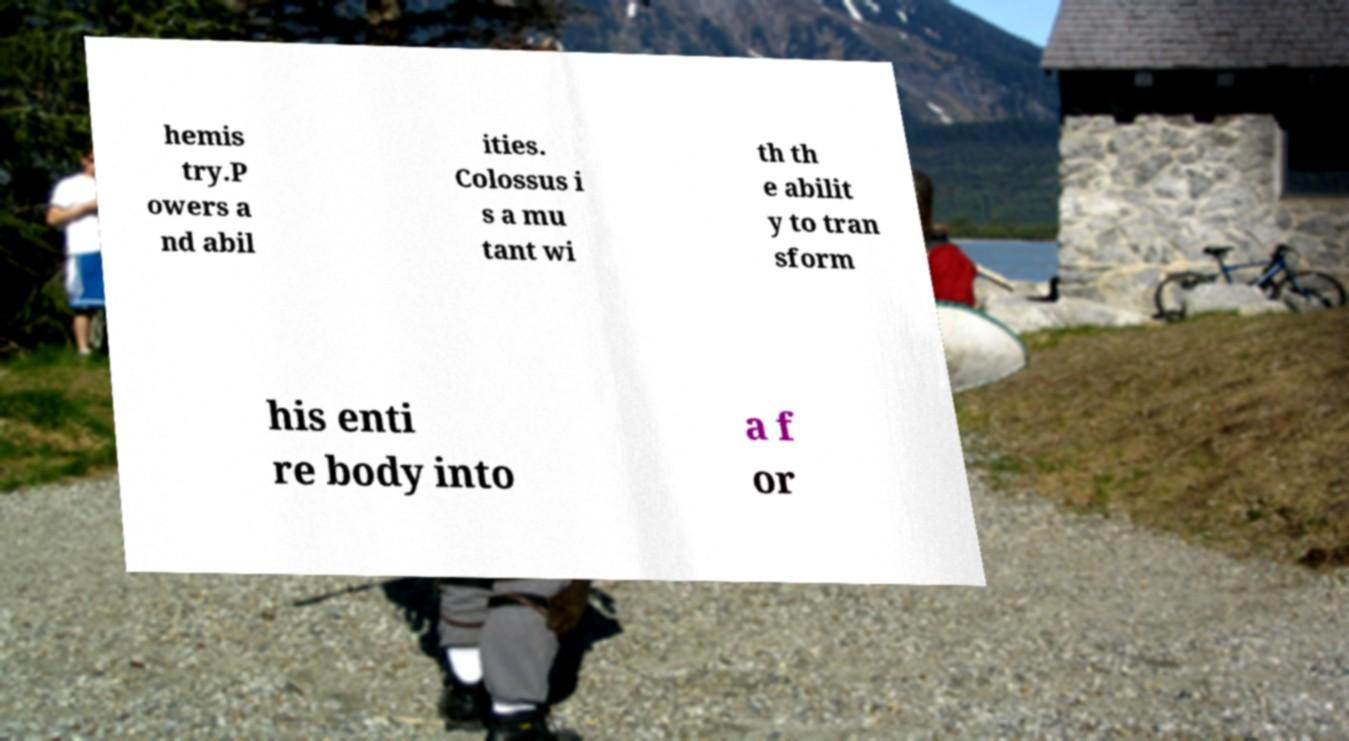Could you assist in decoding the text presented in this image and type it out clearly? hemis try.P owers a nd abil ities. Colossus i s a mu tant wi th th e abilit y to tran sform his enti re body into a f or 